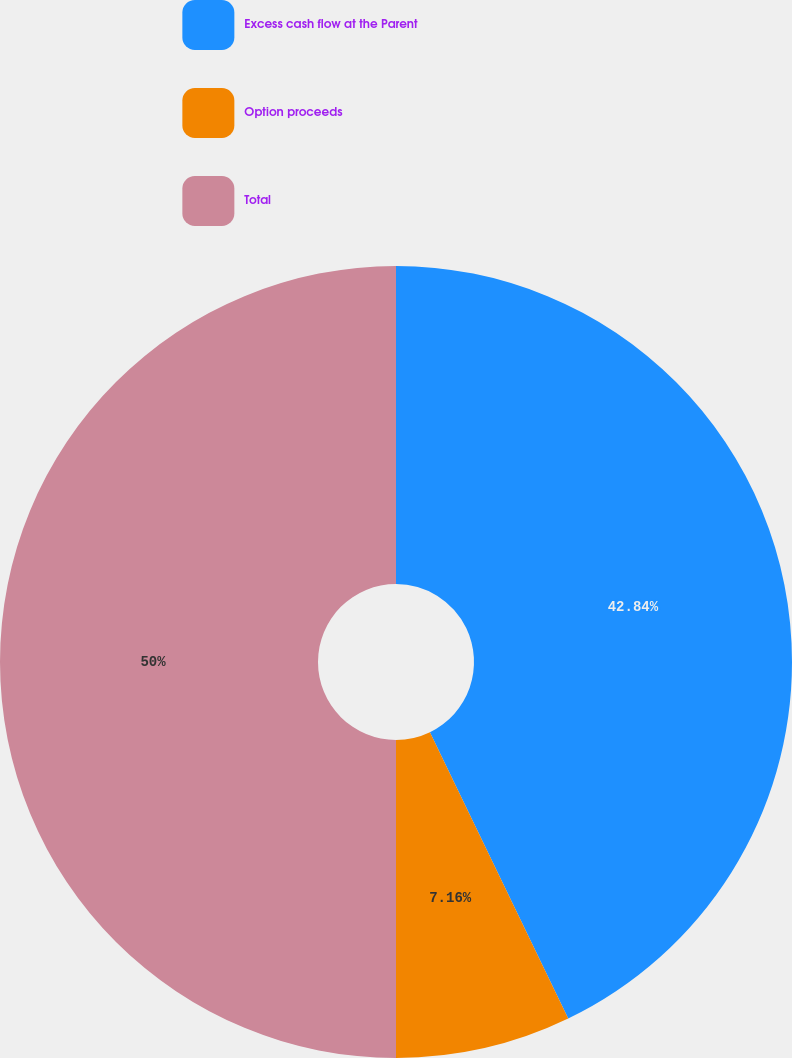<chart> <loc_0><loc_0><loc_500><loc_500><pie_chart><fcel>Excess cash flow at the Parent<fcel>Option proceeds<fcel>Total<nl><fcel>42.84%<fcel>7.16%<fcel>50.0%<nl></chart> 